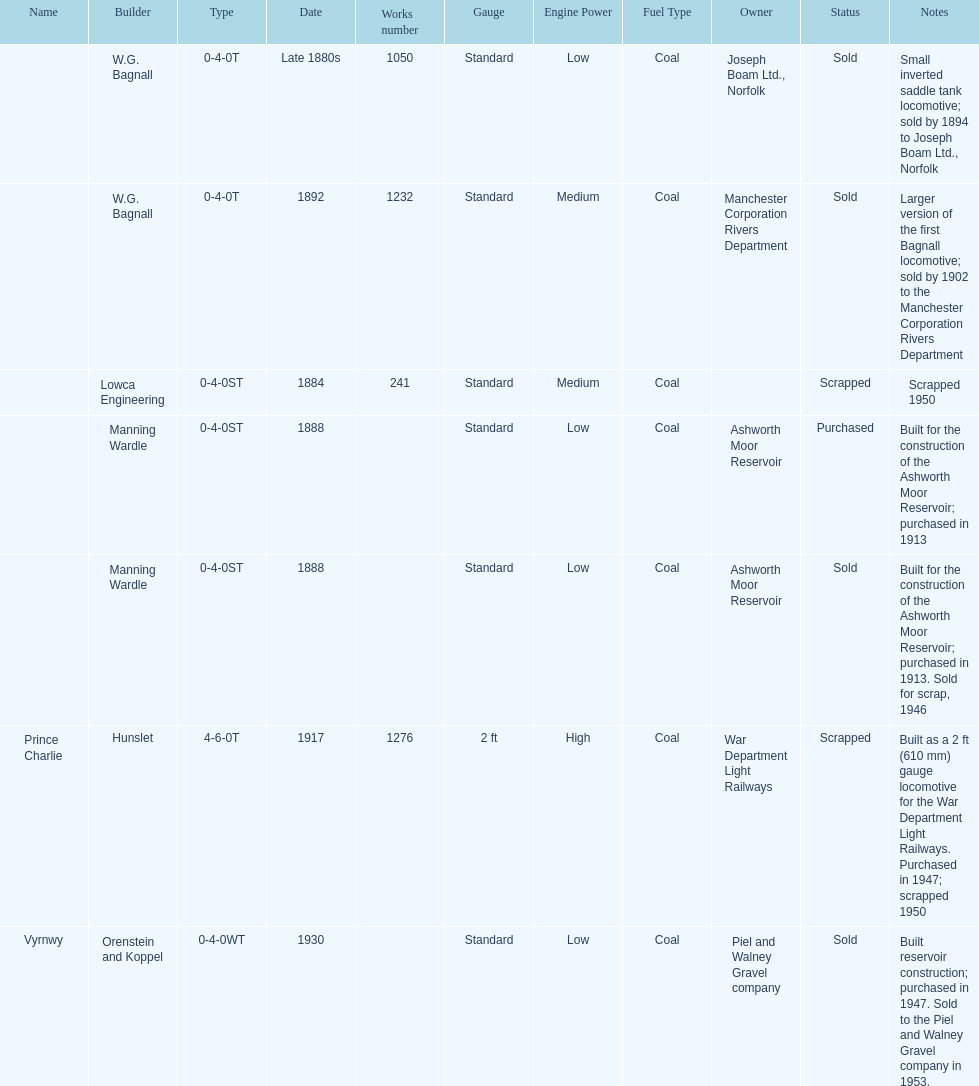How many locomotives were scrapped? 3. 